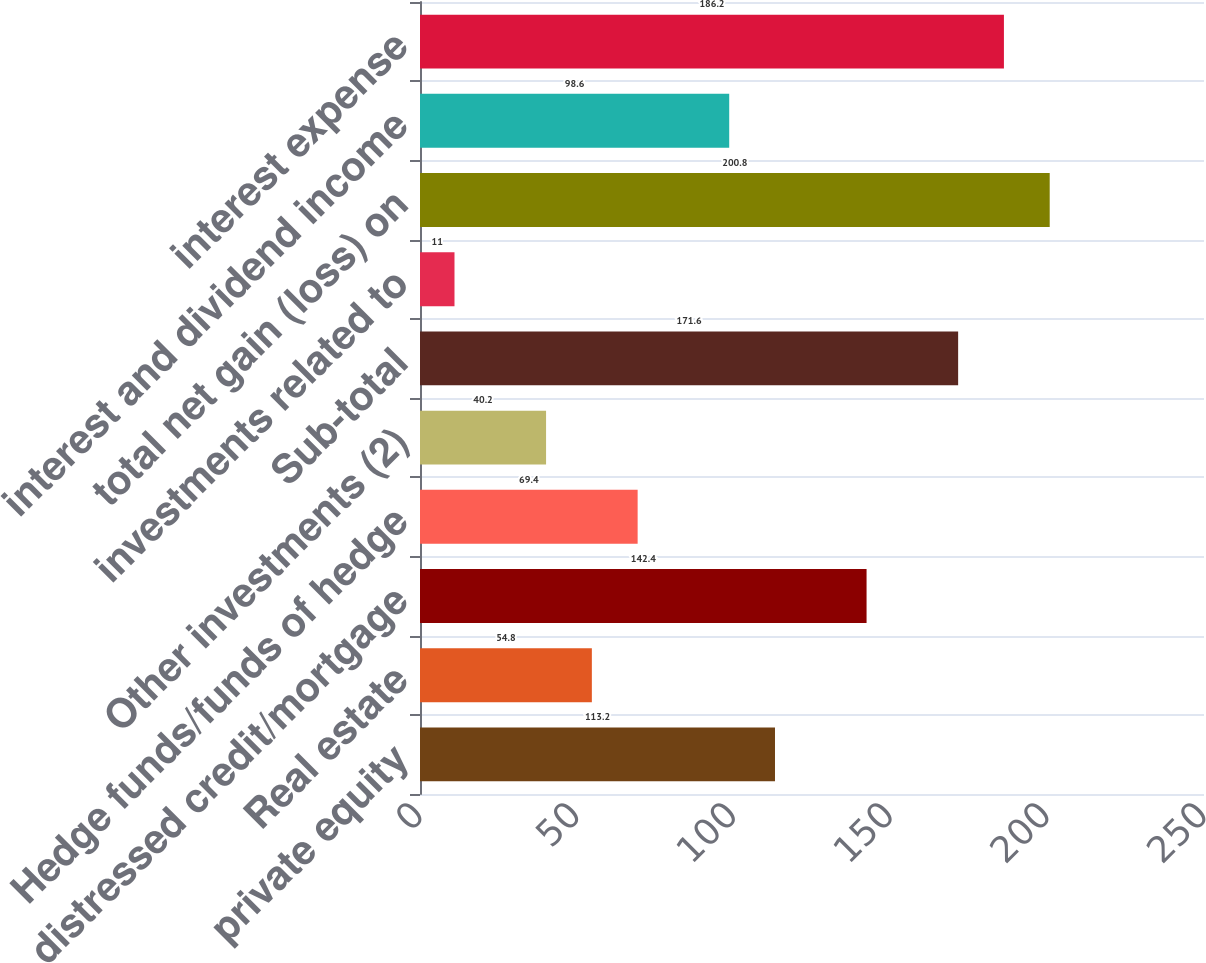<chart> <loc_0><loc_0><loc_500><loc_500><bar_chart><fcel>private equity<fcel>Real estate<fcel>distressed credit/mortgage<fcel>Hedge funds/funds of hedge<fcel>Other investments (2)<fcel>Sub-total<fcel>investments related to<fcel>total net gain (loss) on<fcel>interest and dividend income<fcel>interest expense<nl><fcel>113.2<fcel>54.8<fcel>142.4<fcel>69.4<fcel>40.2<fcel>171.6<fcel>11<fcel>200.8<fcel>98.6<fcel>186.2<nl></chart> 